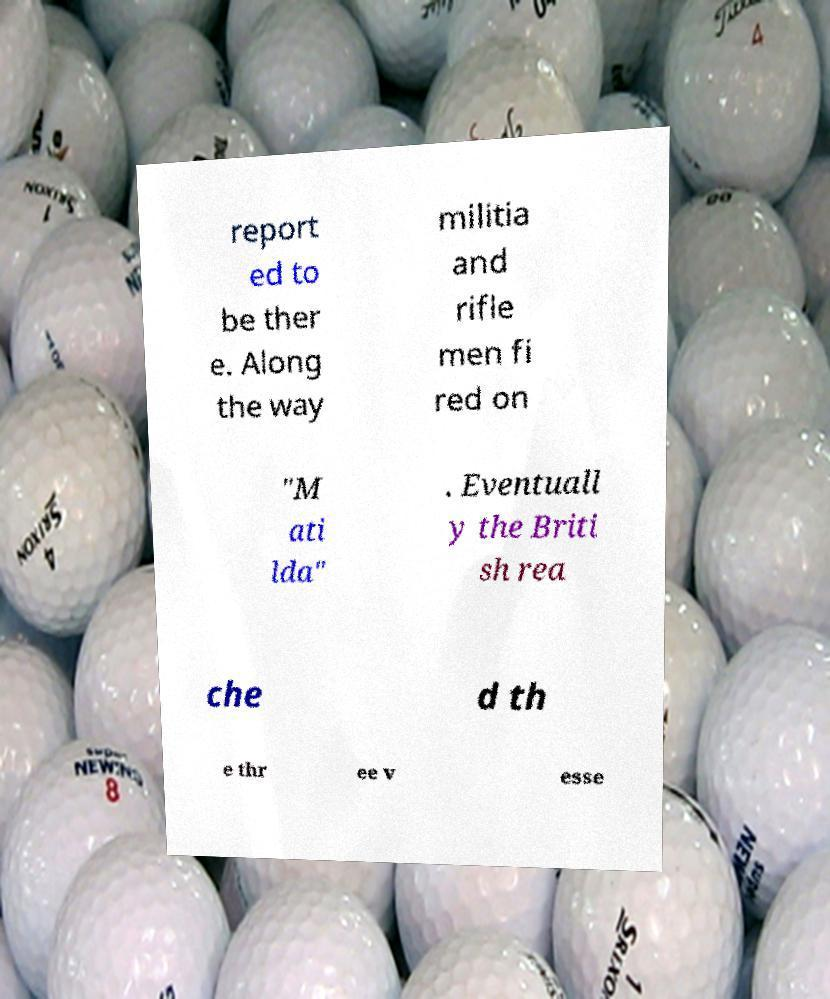Please identify and transcribe the text found in this image. report ed to be ther e. Along the way militia and rifle men fi red on "M ati lda" . Eventuall y the Briti sh rea che d th e thr ee v esse 